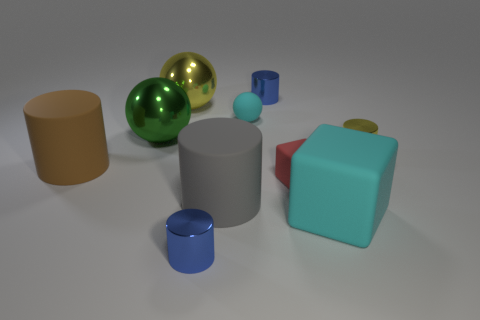There is a tiny yellow shiny thing; what shape is it? The small yellow object in the image appears to be cylindrical, resembling a right circular cylinder with circular ends and a long, straight side. 